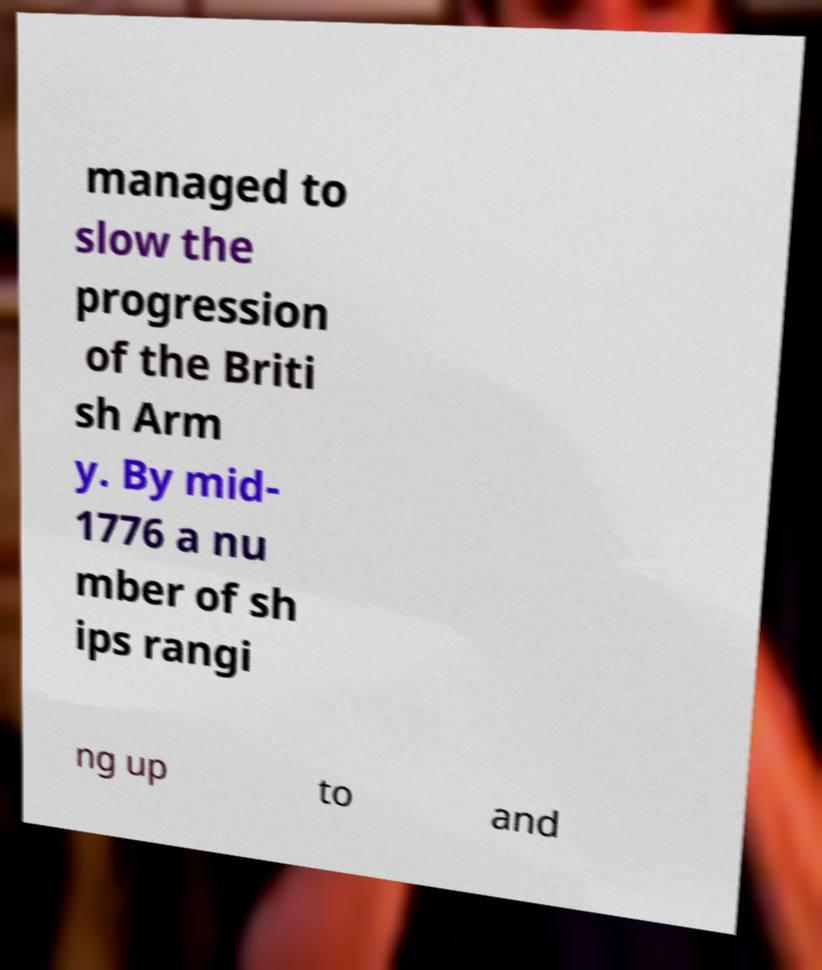Could you extract and type out the text from this image? managed to slow the progression of the Briti sh Arm y. By mid- 1776 a nu mber of sh ips rangi ng up to and 